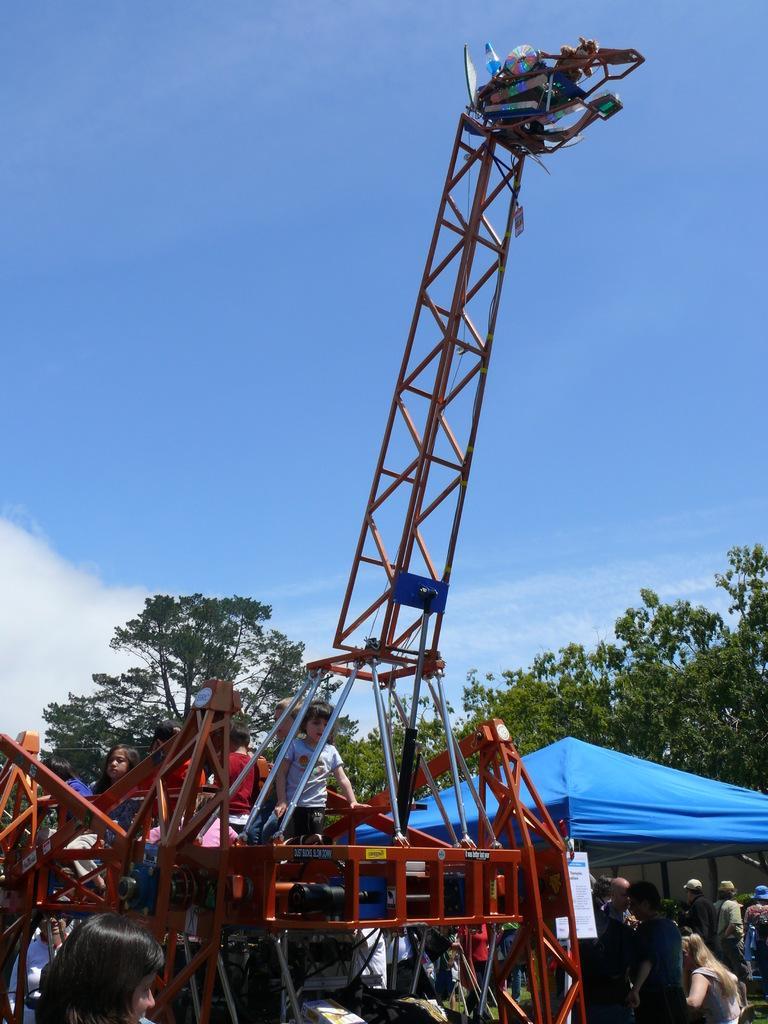In one or two sentences, can you explain what this image depicts? We can see in the image there are few people standing and sitting. In the front there is a rollercoaster, a cloth. Behind the roller coaster there are two trees. On the top there is a sky. 